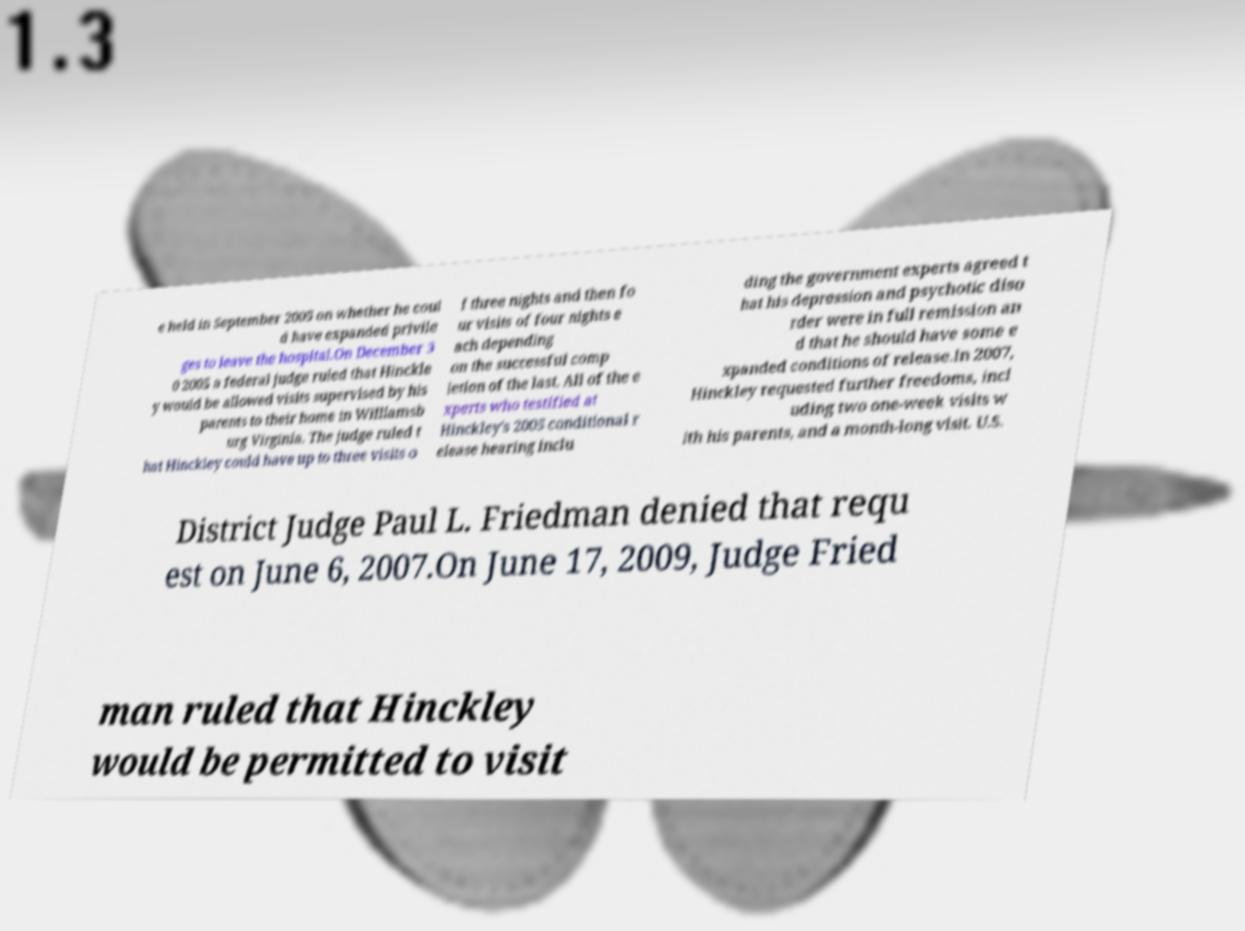For documentation purposes, I need the text within this image transcribed. Could you provide that? e held in September 2005 on whether he coul d have expanded privile ges to leave the hospital.On December 3 0 2005 a federal judge ruled that Hinckle y would be allowed visits supervised by his parents to their home in Williamsb urg Virginia. The judge ruled t hat Hinckley could have up to three visits o f three nights and then fo ur visits of four nights e ach depending on the successful comp letion of the last. All of the e xperts who testified at Hinckley's 2005 conditional r elease hearing inclu ding the government experts agreed t hat his depression and psychotic diso rder were in full remission an d that he should have some e xpanded conditions of release.In 2007, Hinckley requested further freedoms, incl uding two one-week visits w ith his parents, and a month-long visit. U.S. District Judge Paul L. Friedman denied that requ est on June 6, 2007.On June 17, 2009, Judge Fried man ruled that Hinckley would be permitted to visit 